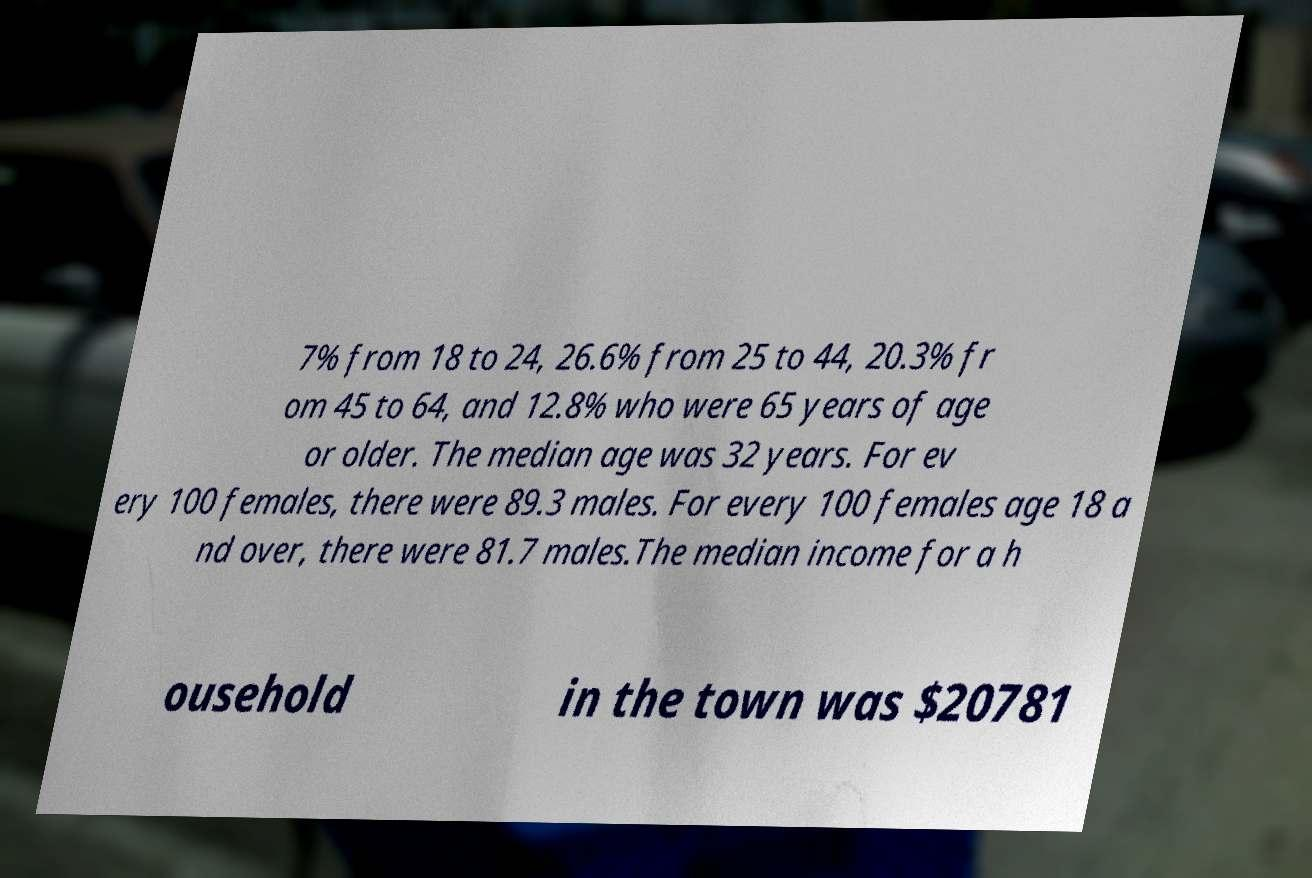Please identify and transcribe the text found in this image. 7% from 18 to 24, 26.6% from 25 to 44, 20.3% fr om 45 to 64, and 12.8% who were 65 years of age or older. The median age was 32 years. For ev ery 100 females, there were 89.3 males. For every 100 females age 18 a nd over, there were 81.7 males.The median income for a h ousehold in the town was $20781 